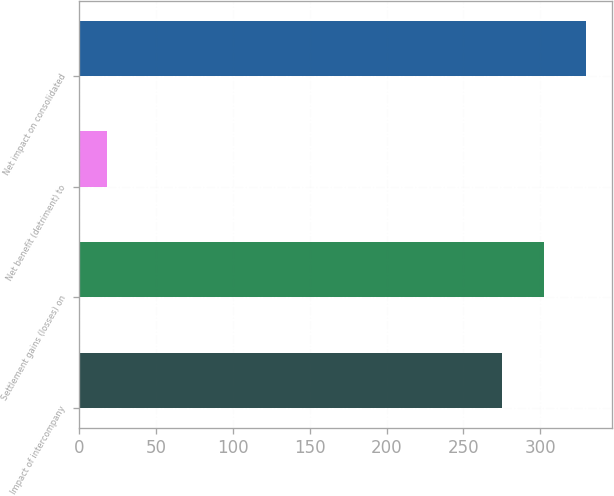Convert chart to OTSL. <chart><loc_0><loc_0><loc_500><loc_500><bar_chart><fcel>Impact of intercompany<fcel>Settlement gains (losses) on<fcel>Net benefit (detriment) to<fcel>Net impact on consolidated<nl><fcel>275<fcel>302.5<fcel>18<fcel>330<nl></chart> 